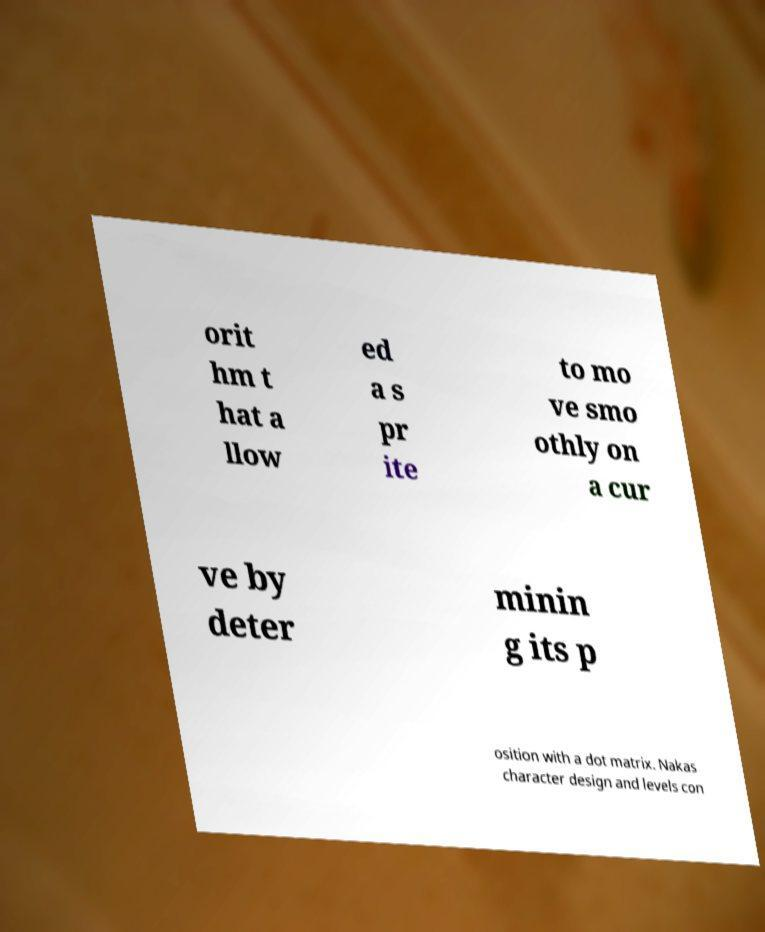Please read and relay the text visible in this image. What does it say? orit hm t hat a llow ed a s pr ite to mo ve smo othly on a cur ve by deter minin g its p osition with a dot matrix. Nakas character design and levels con 